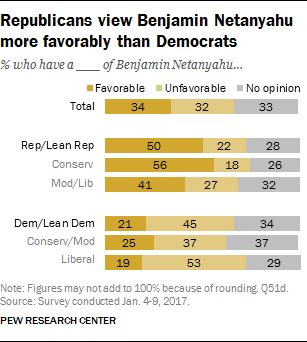Indicate a few pertinent items in this graphic. The average value of all the grey color bars is 31.29. The dark orange color bar represents a favorable outcome. 